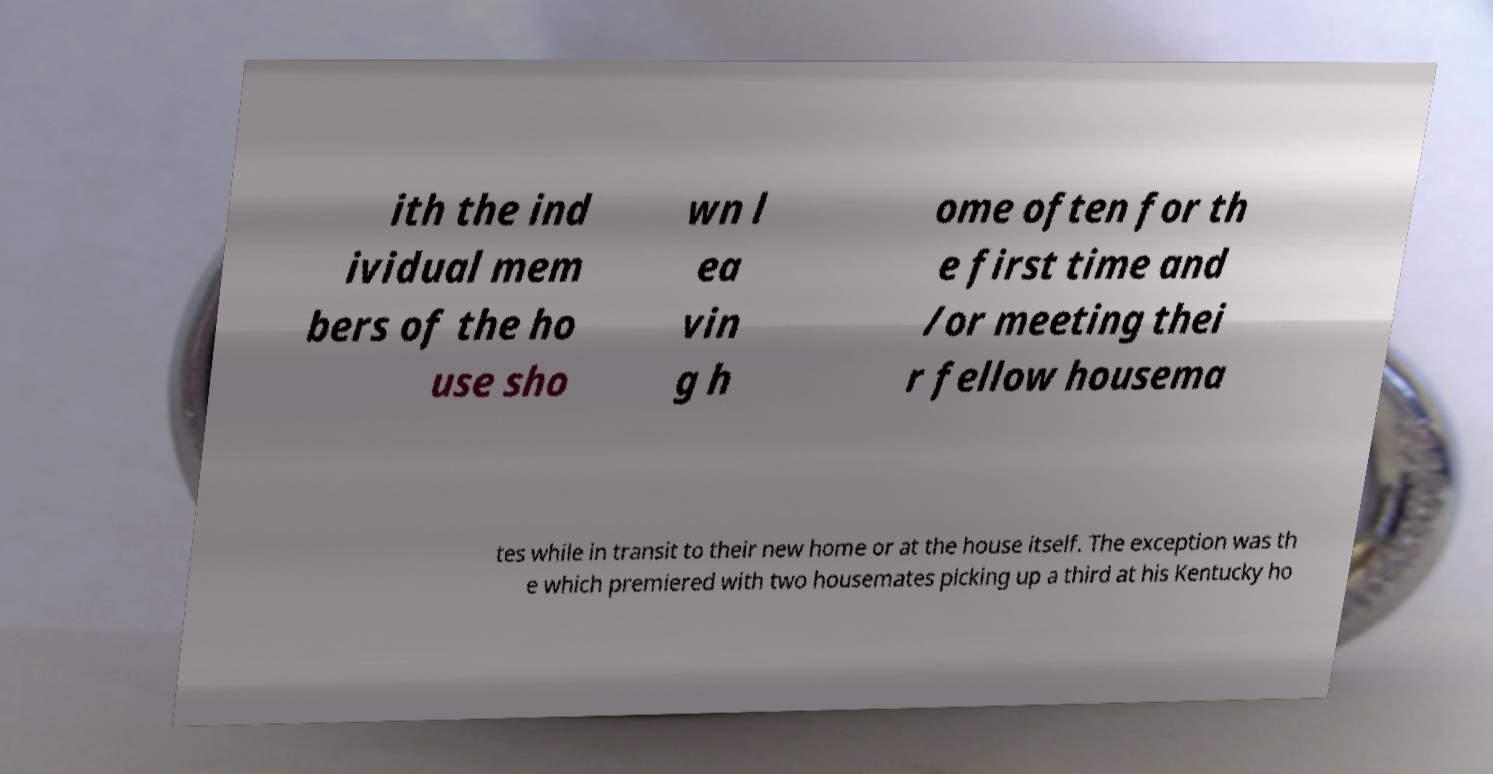Can you read and provide the text displayed in the image?This photo seems to have some interesting text. Can you extract and type it out for me? ith the ind ividual mem bers of the ho use sho wn l ea vin g h ome often for th e first time and /or meeting thei r fellow housema tes while in transit to their new home or at the house itself. The exception was th e which premiered with two housemates picking up a third at his Kentucky ho 